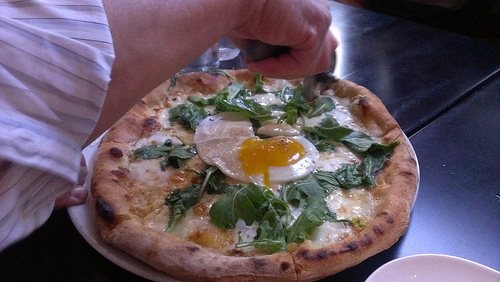Are there potatoes or walnuts in the picture? No, there are no potatoes or walnuts in the picture. 